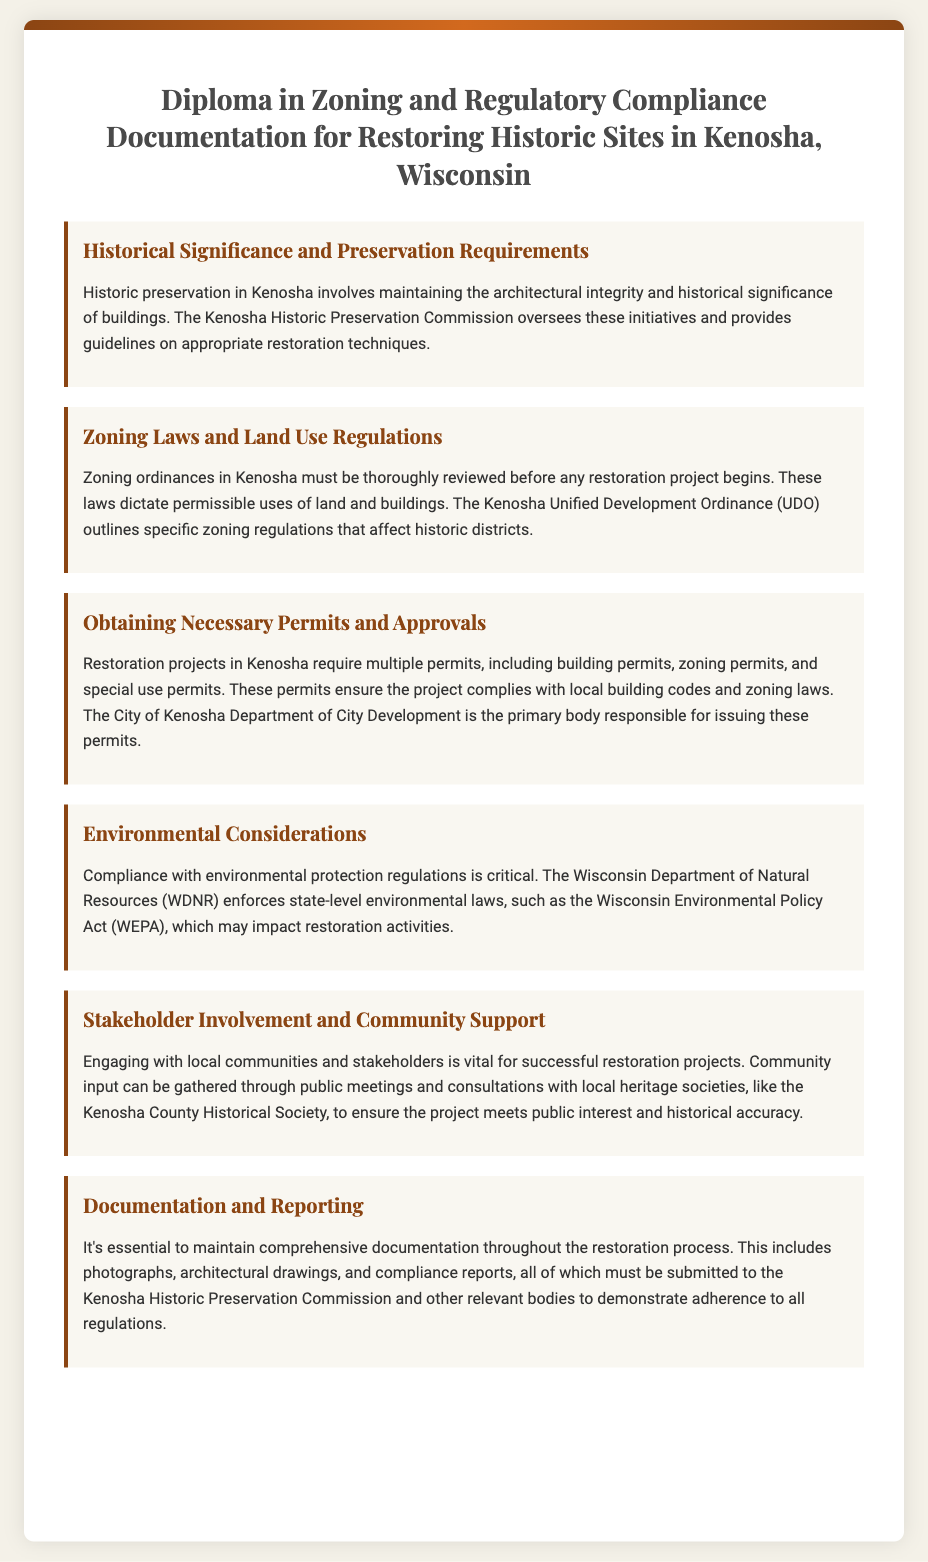What is the title of the diploma? The diploma's title is presented prominently at the top of the document, which reads "Diploma in Zoning and Regulatory Compliance Documentation for Restoring Historic Sites in Kenosha, Wisconsin."
Answer: Diploma in Zoning and Regulatory Compliance Documentation for Restoring Historic Sites in Kenosha, Wisconsin Who oversees historic preservation initiatives in Kenosha? The document specifies that the Kenosha Historic Preservation Commission is responsible for overseeing historic preservation initiatives in the area.
Answer: Kenosha Historic Preservation Commission What is outlined in the Kenosha Unified Development Ordinance? The document mentions that the Kenosha Unified Development Ordinance (UDO) outlines specific zoning regulations affecting historic districts, providing a legal framework for restoring historic sites.
Answer: Specific zoning regulations that affect historic districts Which body issues permits for restoration projects? According to the document, the primary body responsible for issuing necessary permits for restoration projects in Kenosha is the City of Kenosha Department of City Development.
Answer: City of Kenosha Department of City Development What environmental law may impact restoration activities? The document references the Wisconsin Environmental Policy Act (WEPA) as an environmental law that may impact restoration activities in Kenosha.
Answer: Wisconsin Environmental Policy Act What is essential for successful restoration projects? The document highlights that engaging with local communities and stakeholders is vital for the success of restoration projects.
Answer: Engaging with local communities and stakeholders What type of documentation must be maintained during restoration? The document states that comprehensive documentation must be maintained, including photographs, architectural drawings, and compliance reports.
Answer: Photographs, architectural drawings, and compliance reports What does the diploma emphasize about community input? The document emphasizes that community input can be gathered through public meetings and consultations with local heritage societies.
Answer: Community input through public meetings and consultations 